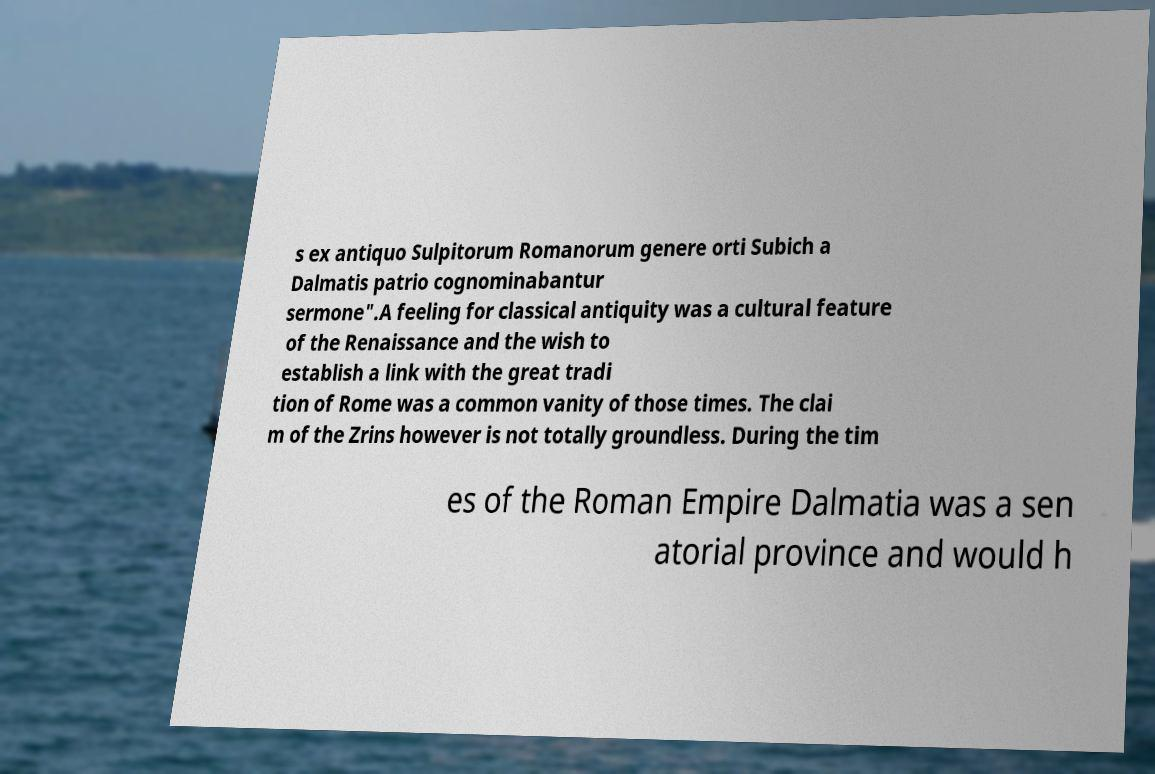For documentation purposes, I need the text within this image transcribed. Could you provide that? s ex antiquo Sulpitorum Romanorum genere orti Subich a Dalmatis patrio cognominabantur sermone".A feeling for classical antiquity was a cultural feature of the Renaissance and the wish to establish a link with the great tradi tion of Rome was a common vanity of those times. The clai m of the Zrins however is not totally groundless. During the tim es of the Roman Empire Dalmatia was a sen atorial province and would h 